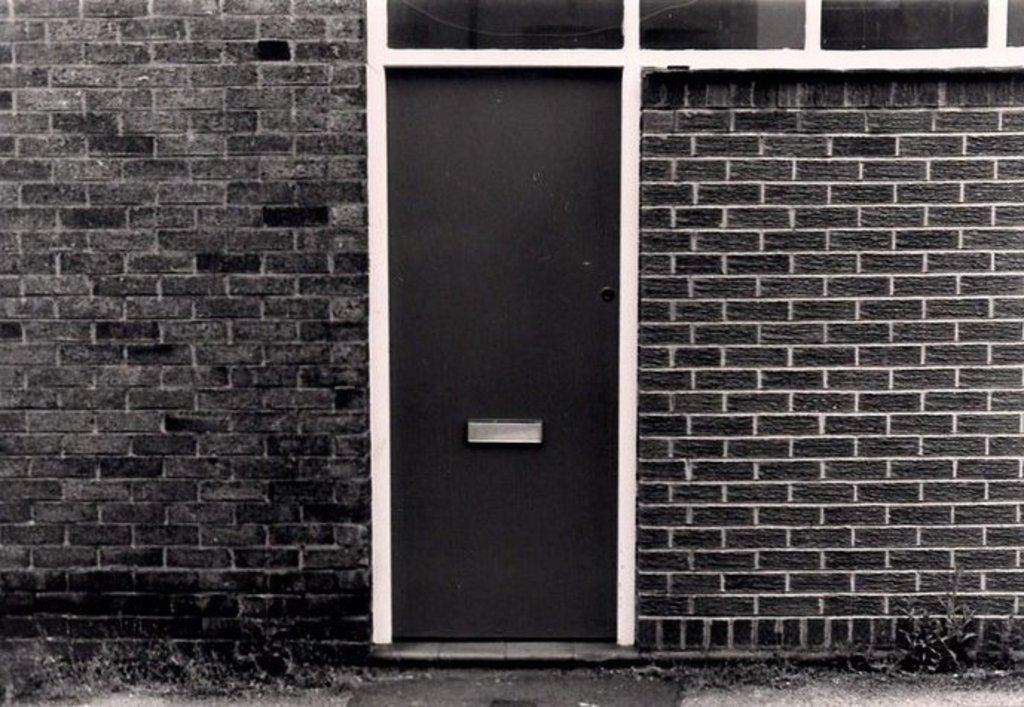What type of structure is visible in the image? There is a house wall in the image. What material is the house wall made of? The house wall has bricks. Where is the door located on the house wall? The door is in the middle of the house wall. What color is the door? The door is black in color. Is there a chin visible on the house wall in the image? No, there is no chin present on the house wall in the image. 